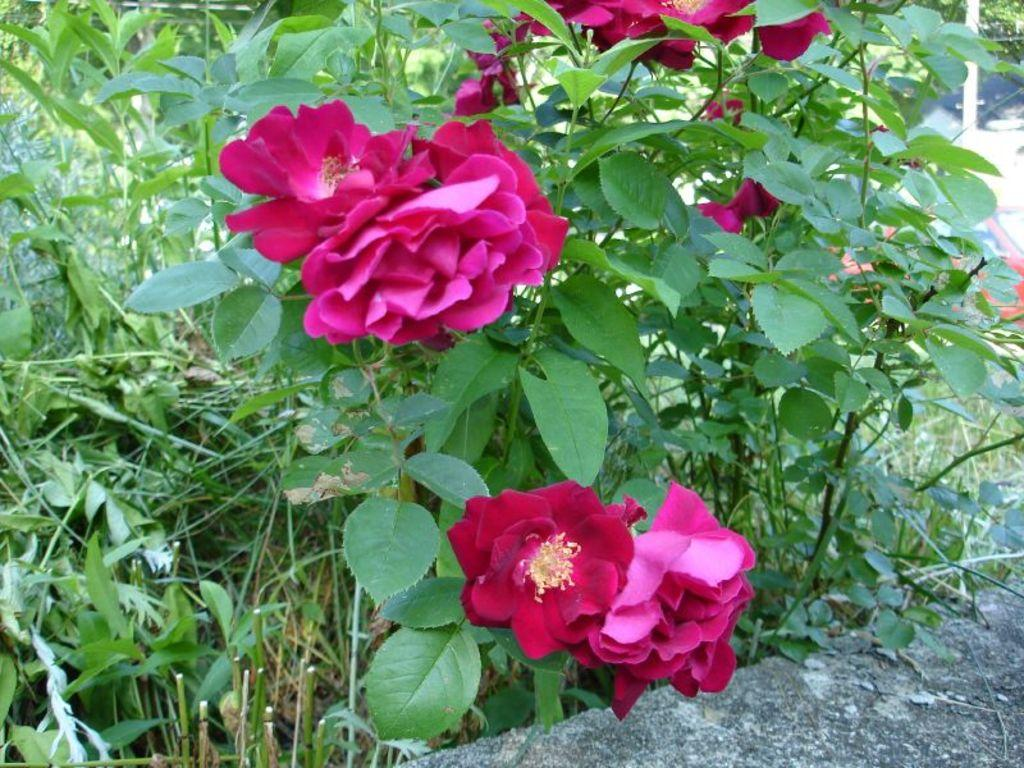What color are the flowers in the image? The flowers in the image are pink. Where are the flowers located? The flowers are on plants. What can be seen in the background of the image? There is a pole and a vehicle in the background of the image. How many wishes can be granted by the harmony of the flowers in the image? There is no mention of wishes or harmony in the image, as it only features pink flowers on plants, a pole, and a vehicle in the background. 